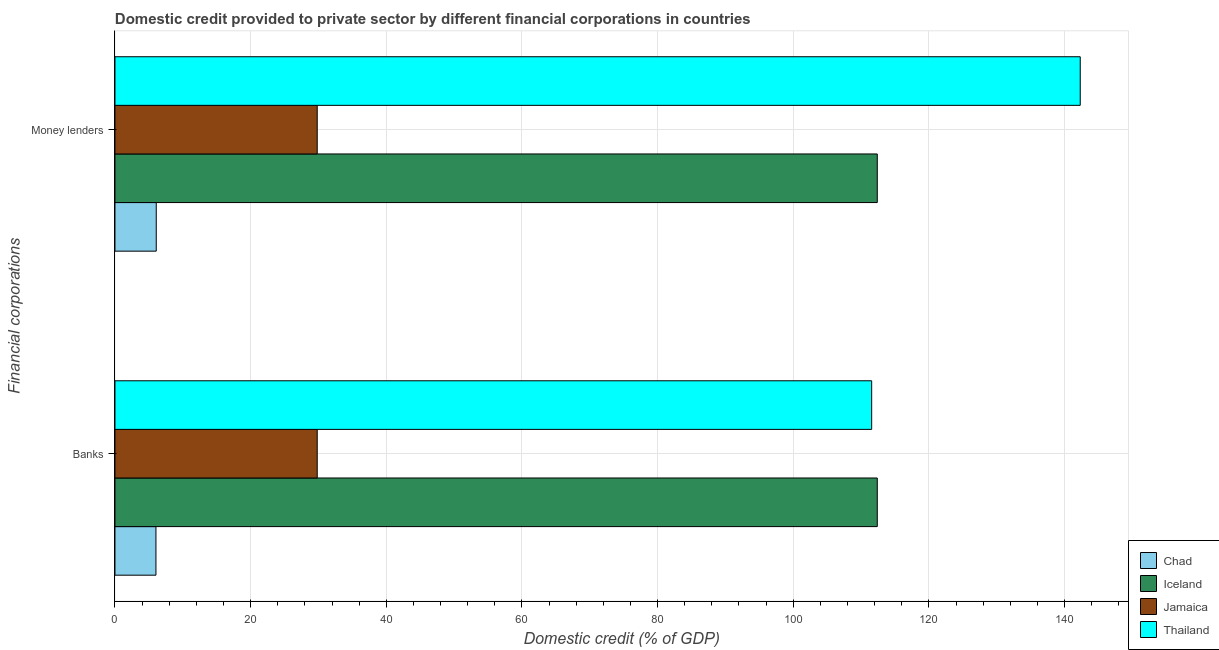How many different coloured bars are there?
Offer a terse response. 4. Are the number of bars per tick equal to the number of legend labels?
Your answer should be compact. Yes. Are the number of bars on each tick of the Y-axis equal?
Your answer should be compact. Yes. How many bars are there on the 2nd tick from the top?
Your answer should be compact. 4. How many bars are there on the 2nd tick from the bottom?
Offer a very short reply. 4. What is the label of the 2nd group of bars from the top?
Provide a succinct answer. Banks. What is the domestic credit provided by money lenders in Thailand?
Make the answer very short. 142.31. Across all countries, what is the maximum domestic credit provided by money lenders?
Provide a short and direct response. 142.31. Across all countries, what is the minimum domestic credit provided by money lenders?
Make the answer very short. 6.09. In which country was the domestic credit provided by money lenders maximum?
Make the answer very short. Thailand. In which country was the domestic credit provided by money lenders minimum?
Make the answer very short. Chad. What is the total domestic credit provided by money lenders in the graph?
Make the answer very short. 290.61. What is the difference between the domestic credit provided by money lenders in Iceland and that in Jamaica?
Offer a very short reply. 82.57. What is the difference between the domestic credit provided by money lenders in Jamaica and the domestic credit provided by banks in Chad?
Offer a very short reply. 23.78. What is the average domestic credit provided by banks per country?
Ensure brevity in your answer.  64.96. What is the difference between the domestic credit provided by banks and domestic credit provided by money lenders in Thailand?
Give a very brief answer. -30.75. What is the ratio of the domestic credit provided by money lenders in Jamaica to that in Chad?
Offer a terse response. 4.9. Is the domestic credit provided by banks in Chad less than that in Thailand?
Offer a terse response. Yes. What does the 1st bar from the top in Money lenders represents?
Your answer should be very brief. Thailand. What does the 1st bar from the bottom in Money lenders represents?
Make the answer very short. Chad. Are all the bars in the graph horizontal?
Make the answer very short. Yes. How many countries are there in the graph?
Provide a succinct answer. 4. What is the difference between two consecutive major ticks on the X-axis?
Offer a terse response. 20. Are the values on the major ticks of X-axis written in scientific E-notation?
Your response must be concise. No. Does the graph contain any zero values?
Keep it short and to the point. No. Does the graph contain grids?
Your answer should be compact. Yes. Where does the legend appear in the graph?
Provide a succinct answer. Bottom right. What is the title of the graph?
Make the answer very short. Domestic credit provided to private sector by different financial corporations in countries. Does "Niger" appear as one of the legend labels in the graph?
Ensure brevity in your answer.  No. What is the label or title of the X-axis?
Provide a succinct answer. Domestic credit (% of GDP). What is the label or title of the Y-axis?
Your response must be concise. Financial corporations. What is the Domestic credit (% of GDP) of Chad in Banks?
Your answer should be compact. 6.04. What is the Domestic credit (% of GDP) of Iceland in Banks?
Your answer should be compact. 112.39. What is the Domestic credit (% of GDP) of Jamaica in Banks?
Your answer should be compact. 29.82. What is the Domestic credit (% of GDP) of Thailand in Banks?
Provide a succinct answer. 111.56. What is the Domestic credit (% of GDP) of Chad in Money lenders?
Make the answer very short. 6.09. What is the Domestic credit (% of GDP) of Iceland in Money lenders?
Keep it short and to the point. 112.39. What is the Domestic credit (% of GDP) in Jamaica in Money lenders?
Provide a succinct answer. 29.82. What is the Domestic credit (% of GDP) in Thailand in Money lenders?
Give a very brief answer. 142.31. Across all Financial corporations, what is the maximum Domestic credit (% of GDP) in Chad?
Ensure brevity in your answer.  6.09. Across all Financial corporations, what is the maximum Domestic credit (% of GDP) of Iceland?
Ensure brevity in your answer.  112.39. Across all Financial corporations, what is the maximum Domestic credit (% of GDP) in Jamaica?
Offer a very short reply. 29.82. Across all Financial corporations, what is the maximum Domestic credit (% of GDP) in Thailand?
Your answer should be compact. 142.31. Across all Financial corporations, what is the minimum Domestic credit (% of GDP) in Chad?
Your response must be concise. 6.04. Across all Financial corporations, what is the minimum Domestic credit (% of GDP) in Iceland?
Offer a very short reply. 112.39. Across all Financial corporations, what is the minimum Domestic credit (% of GDP) of Jamaica?
Give a very brief answer. 29.82. Across all Financial corporations, what is the minimum Domestic credit (% of GDP) of Thailand?
Your answer should be very brief. 111.56. What is the total Domestic credit (% of GDP) in Chad in the graph?
Offer a terse response. 12.13. What is the total Domestic credit (% of GDP) of Iceland in the graph?
Provide a short and direct response. 224.78. What is the total Domestic credit (% of GDP) of Jamaica in the graph?
Your answer should be very brief. 59.64. What is the total Domestic credit (% of GDP) of Thailand in the graph?
Offer a terse response. 253.88. What is the difference between the Domestic credit (% of GDP) of Chad in Banks and that in Money lenders?
Give a very brief answer. -0.05. What is the difference between the Domestic credit (% of GDP) in Iceland in Banks and that in Money lenders?
Provide a short and direct response. 0. What is the difference between the Domestic credit (% of GDP) in Jamaica in Banks and that in Money lenders?
Provide a short and direct response. 0. What is the difference between the Domestic credit (% of GDP) in Thailand in Banks and that in Money lenders?
Your answer should be very brief. -30.75. What is the difference between the Domestic credit (% of GDP) in Chad in Banks and the Domestic credit (% of GDP) in Iceland in Money lenders?
Provide a succinct answer. -106.35. What is the difference between the Domestic credit (% of GDP) of Chad in Banks and the Domestic credit (% of GDP) of Jamaica in Money lenders?
Your response must be concise. -23.78. What is the difference between the Domestic credit (% of GDP) of Chad in Banks and the Domestic credit (% of GDP) of Thailand in Money lenders?
Your answer should be compact. -136.27. What is the difference between the Domestic credit (% of GDP) in Iceland in Banks and the Domestic credit (% of GDP) in Jamaica in Money lenders?
Make the answer very short. 82.57. What is the difference between the Domestic credit (% of GDP) of Iceland in Banks and the Domestic credit (% of GDP) of Thailand in Money lenders?
Your response must be concise. -29.92. What is the difference between the Domestic credit (% of GDP) in Jamaica in Banks and the Domestic credit (% of GDP) in Thailand in Money lenders?
Your answer should be very brief. -112.49. What is the average Domestic credit (% of GDP) in Chad per Financial corporations?
Make the answer very short. 6.07. What is the average Domestic credit (% of GDP) in Iceland per Financial corporations?
Your response must be concise. 112.39. What is the average Domestic credit (% of GDP) of Jamaica per Financial corporations?
Your answer should be compact. 29.82. What is the average Domestic credit (% of GDP) of Thailand per Financial corporations?
Offer a terse response. 126.94. What is the difference between the Domestic credit (% of GDP) in Chad and Domestic credit (% of GDP) in Iceland in Banks?
Provide a succinct answer. -106.35. What is the difference between the Domestic credit (% of GDP) in Chad and Domestic credit (% of GDP) in Jamaica in Banks?
Make the answer very short. -23.78. What is the difference between the Domestic credit (% of GDP) of Chad and Domestic credit (% of GDP) of Thailand in Banks?
Ensure brevity in your answer.  -105.52. What is the difference between the Domestic credit (% of GDP) of Iceland and Domestic credit (% of GDP) of Jamaica in Banks?
Make the answer very short. 82.57. What is the difference between the Domestic credit (% of GDP) in Iceland and Domestic credit (% of GDP) in Thailand in Banks?
Your answer should be very brief. 0.83. What is the difference between the Domestic credit (% of GDP) in Jamaica and Domestic credit (% of GDP) in Thailand in Banks?
Ensure brevity in your answer.  -81.74. What is the difference between the Domestic credit (% of GDP) of Chad and Domestic credit (% of GDP) of Iceland in Money lenders?
Your response must be concise. -106.3. What is the difference between the Domestic credit (% of GDP) in Chad and Domestic credit (% of GDP) in Jamaica in Money lenders?
Make the answer very short. -23.73. What is the difference between the Domestic credit (% of GDP) in Chad and Domestic credit (% of GDP) in Thailand in Money lenders?
Offer a terse response. -136.22. What is the difference between the Domestic credit (% of GDP) of Iceland and Domestic credit (% of GDP) of Jamaica in Money lenders?
Give a very brief answer. 82.57. What is the difference between the Domestic credit (% of GDP) in Iceland and Domestic credit (% of GDP) in Thailand in Money lenders?
Provide a short and direct response. -29.92. What is the difference between the Domestic credit (% of GDP) in Jamaica and Domestic credit (% of GDP) in Thailand in Money lenders?
Provide a succinct answer. -112.49. What is the ratio of the Domestic credit (% of GDP) in Chad in Banks to that in Money lenders?
Provide a short and direct response. 0.99. What is the ratio of the Domestic credit (% of GDP) in Jamaica in Banks to that in Money lenders?
Offer a terse response. 1. What is the ratio of the Domestic credit (% of GDP) of Thailand in Banks to that in Money lenders?
Your answer should be very brief. 0.78. What is the difference between the highest and the second highest Domestic credit (% of GDP) of Chad?
Your answer should be compact. 0.05. What is the difference between the highest and the second highest Domestic credit (% of GDP) of Iceland?
Provide a short and direct response. 0. What is the difference between the highest and the second highest Domestic credit (% of GDP) of Jamaica?
Your answer should be very brief. 0. What is the difference between the highest and the second highest Domestic credit (% of GDP) in Thailand?
Your answer should be compact. 30.75. What is the difference between the highest and the lowest Domestic credit (% of GDP) in Chad?
Ensure brevity in your answer.  0.05. What is the difference between the highest and the lowest Domestic credit (% of GDP) of Iceland?
Offer a terse response. 0. What is the difference between the highest and the lowest Domestic credit (% of GDP) in Thailand?
Provide a short and direct response. 30.75. 